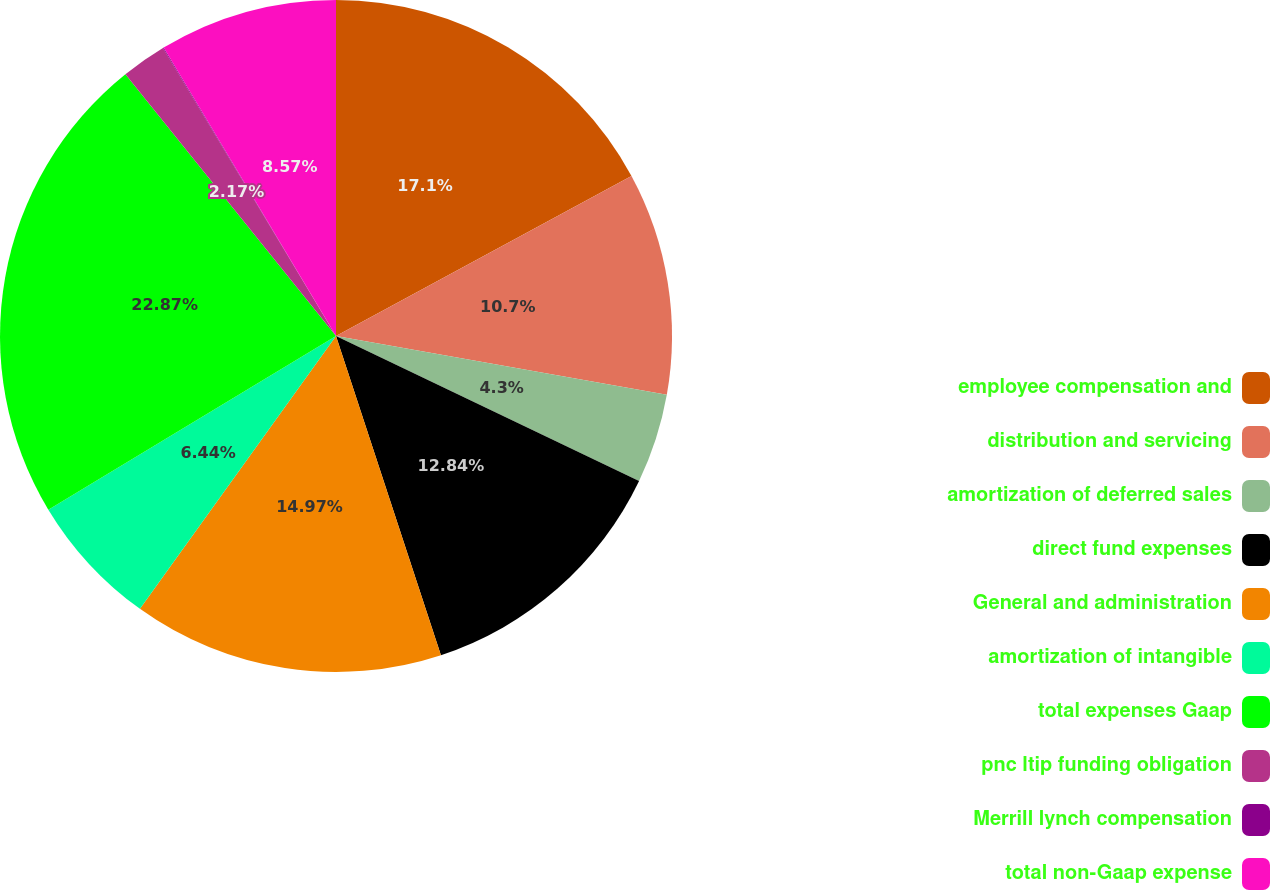Convert chart to OTSL. <chart><loc_0><loc_0><loc_500><loc_500><pie_chart><fcel>employee compensation and<fcel>distribution and servicing<fcel>amortization of deferred sales<fcel>direct fund expenses<fcel>General and administration<fcel>amortization of intangible<fcel>total expenses Gaap<fcel>pnc ltip funding obligation<fcel>Merrill lynch compensation<fcel>total non-Gaap expense<nl><fcel>17.1%<fcel>10.7%<fcel>4.3%<fcel>12.84%<fcel>14.97%<fcel>6.44%<fcel>22.86%<fcel>2.17%<fcel>0.04%<fcel>8.57%<nl></chart> 